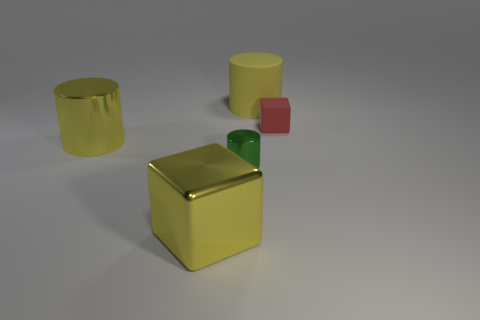There is a rubber cylinder that is right of the yellow metal cylinder; is it the same color as the large cylinder that is on the left side of the rubber cylinder?
Offer a terse response. Yes. Is there a yellow thing made of the same material as the red thing?
Your answer should be compact. Yes. The big shiny block is what color?
Make the answer very short. Yellow. There is a cube behind the big yellow cylinder left of the big cylinder right of the large yellow cube; how big is it?
Make the answer very short. Small. What number of other things are the same shape as the large rubber thing?
Make the answer very short. 2. There is a object that is on the right side of the tiny cylinder and left of the tiny cube; what color is it?
Offer a very short reply. Yellow. Do the big block that is on the left side of the big yellow rubber thing and the big matte cylinder have the same color?
Offer a very short reply. Yes. What number of spheres are tiny green things or cyan things?
Give a very brief answer. 0. There is a rubber object that is in front of the large yellow rubber cylinder; what shape is it?
Make the answer very short. Cube. There is a matte object that is right of the yellow cylinder that is behind the yellow metallic object that is left of the metal cube; what is its color?
Your answer should be very brief. Red. 